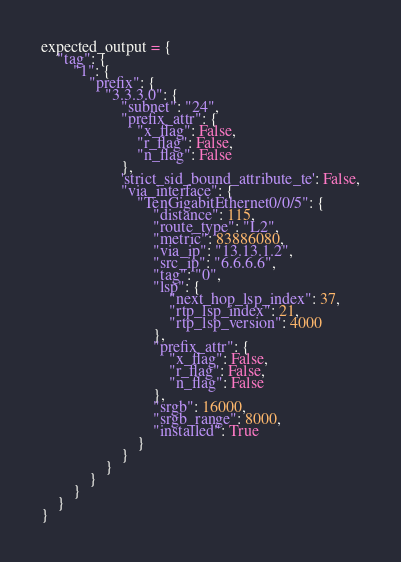<code> <loc_0><loc_0><loc_500><loc_500><_Python_>expected_output = {
    "tag": {
        "1": {
            "prefix": {
                "3.3.3.0": {
                    "subnet": "24",
                    "prefix_attr": {
                        "x_flag": False,
                        "r_flag": False,
                        "n_flag": False
                    },
                    'strict_sid_bound_attribute_te': False,
                    "via_interface": {
                        "TenGigabitEthernet0/0/5": {
                            "distance": 115,
                            "route_type": "L2",
                            "metric": 83886080,
                            "via_ip": "13.13.1.2",
                            "src_ip": "6.6.6.6",
                            "tag": "0",
                            "lsp": {
                                "next_hop_lsp_index": 37,
                                "rtp_lsp_index": 21,
                                "rtp_lsp_version": 4000
                            },
                            "prefix_attr": {
                                "x_flag": False,
                                "r_flag": False,
                                "n_flag": False
                            },
                            "srgb": 16000,
                            "srgb_range": 8000,
                            "installed": True
                        }
                    }
                }
            }
        }
    }
}</code> 